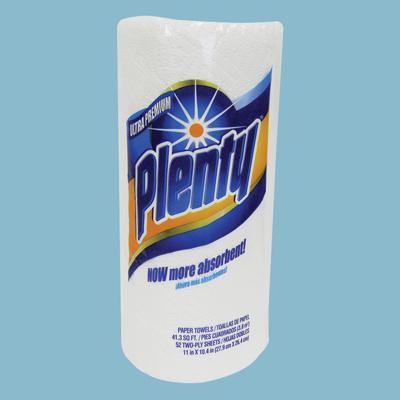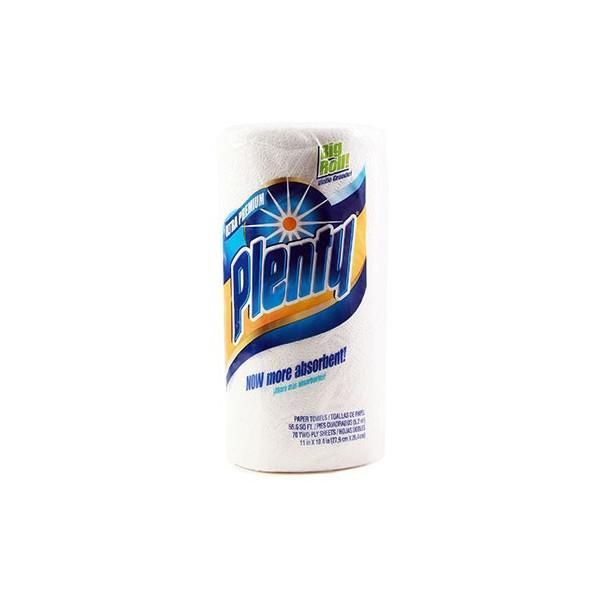The first image is the image on the left, the second image is the image on the right. Given the left and right images, does the statement "The package of paper towel in the image on the left contains more than 6 rolls." hold true? Answer yes or no. No. The first image is the image on the left, the second image is the image on the right. For the images displayed, is the sentence "Right and left images show paper towel packs with blue and orange colors on the packaging, all packs feature a sunburst, and at least one features a red plus-sign." factually correct? Answer yes or no. No. 